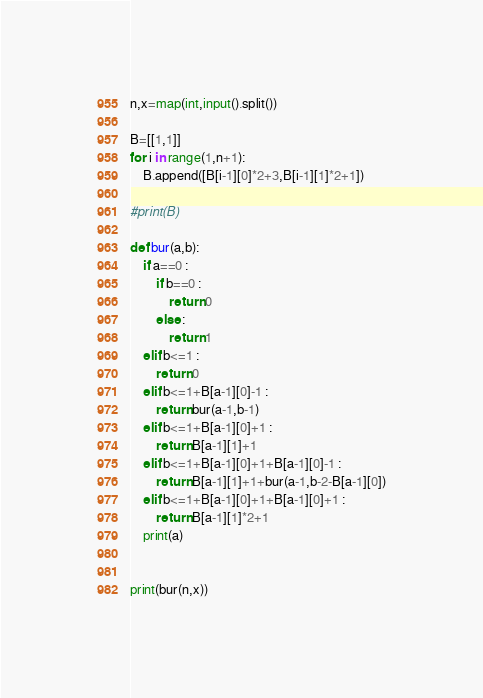Convert code to text. <code><loc_0><loc_0><loc_500><loc_500><_Python_>n,x=map(int,input().split())

B=[[1,1]]
for i in range(1,n+1):
    B.append([B[i-1][0]*2+3,B[i-1][1]*2+1])

#print(B)

def bur(a,b):
    if a==0 :
        if b==0 :
            return 0
        else :
            return 1
    elif b<=1 :
        return 0
    elif b<=1+B[a-1][0]-1 :
        return bur(a-1,b-1)
    elif b<=1+B[a-1][0]+1 :
        return B[a-1][1]+1
    elif b<=1+B[a-1][0]+1+B[a-1][0]-1 :
        return B[a-1][1]+1+bur(a-1,b-2-B[a-1][0])
    elif b<=1+B[a-1][0]+1+B[a-1][0]+1 :
        return B[a-1][1]*2+1
    print(a)
    

print(bur(n,x))
</code> 